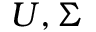Convert formula to latex. <formula><loc_0><loc_0><loc_500><loc_500>U , \Sigma</formula> 